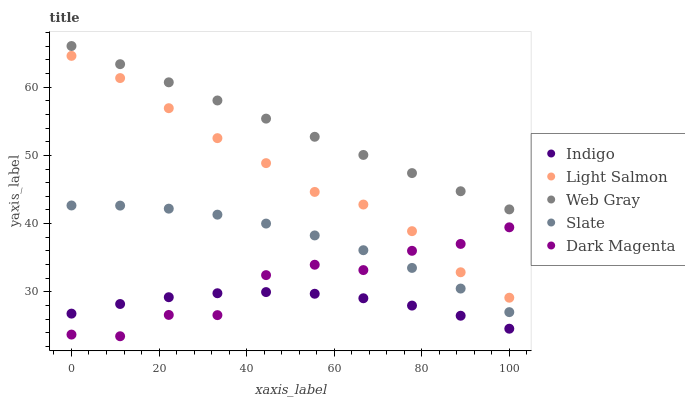Does Indigo have the minimum area under the curve?
Answer yes or no. Yes. Does Web Gray have the maximum area under the curve?
Answer yes or no. Yes. Does Web Gray have the minimum area under the curve?
Answer yes or no. No. Does Indigo have the maximum area under the curve?
Answer yes or no. No. Is Web Gray the smoothest?
Answer yes or no. Yes. Is Dark Magenta the roughest?
Answer yes or no. Yes. Is Indigo the smoothest?
Answer yes or no. No. Is Indigo the roughest?
Answer yes or no. No. Does Dark Magenta have the lowest value?
Answer yes or no. Yes. Does Indigo have the lowest value?
Answer yes or no. No. Does Web Gray have the highest value?
Answer yes or no. Yes. Does Indigo have the highest value?
Answer yes or no. No. Is Slate less than Light Salmon?
Answer yes or no. Yes. Is Web Gray greater than Indigo?
Answer yes or no. Yes. Does Dark Magenta intersect Light Salmon?
Answer yes or no. Yes. Is Dark Magenta less than Light Salmon?
Answer yes or no. No. Is Dark Magenta greater than Light Salmon?
Answer yes or no. No. Does Slate intersect Light Salmon?
Answer yes or no. No. 